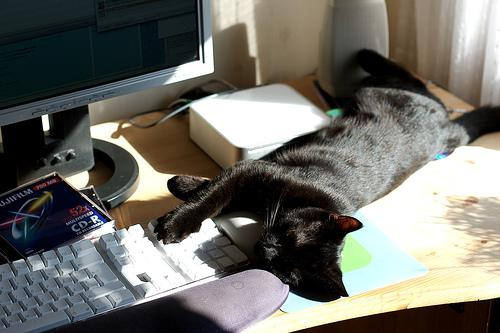Question: what is on a desk?
Choices:
A. A Book.
B. A cup.
C. A plant.
D. A cat.
Answer with the letter. Answer: D Question: where is a computer?
Choices:
A. On the chair.
B. On the wall.
C. In the bag.
D. On a desk.
Answer with the letter. Answer: D Question: what is black?
Choices:
A. Door.
B. Wheel.
C. Building.
D. Cat.
Answer with the letter. Answer: D Question: what has whiskers?
Choices:
A. The cat.
B. Horse.
C. Hamster.
D. Rat.
Answer with the letter. Answer: A Question: what is white?
Choices:
A. Computer keys.
B. Polar bear.
C. Piano keys.
D. Kitten.
Answer with the letter. Answer: A 